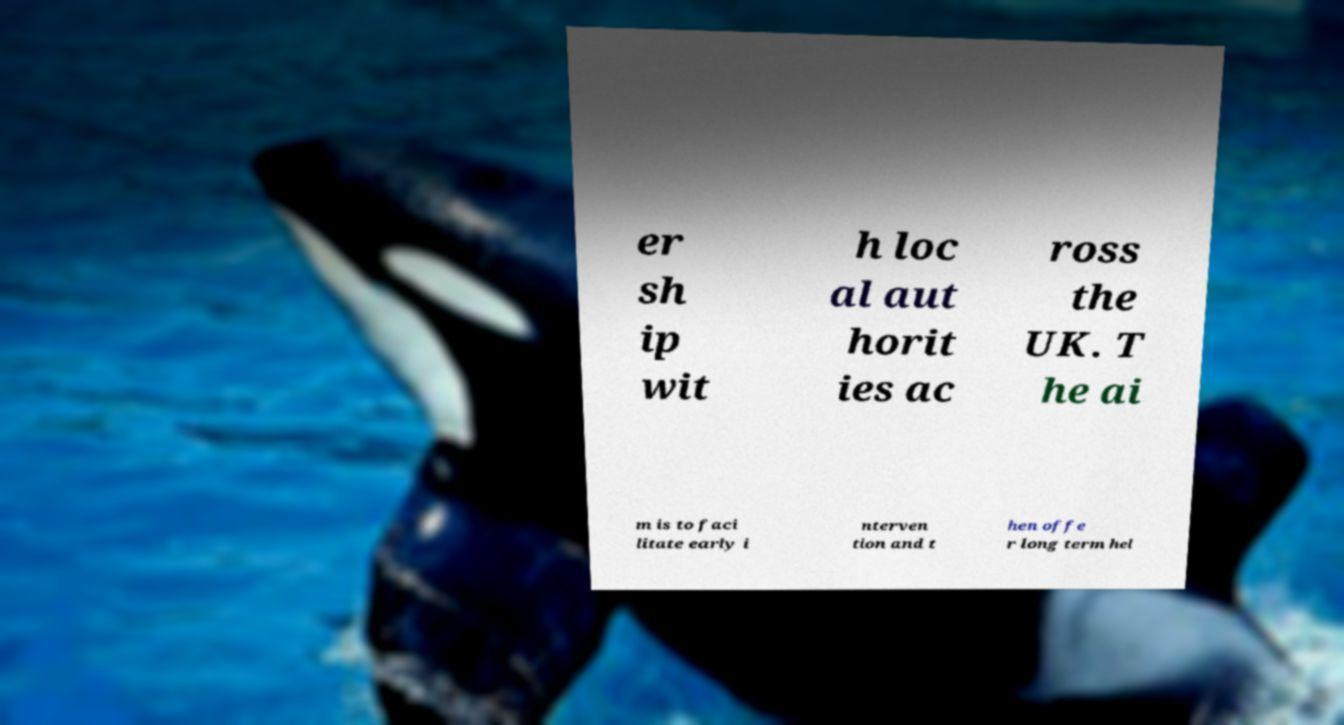Could you assist in decoding the text presented in this image and type it out clearly? er sh ip wit h loc al aut horit ies ac ross the UK. T he ai m is to faci litate early i nterven tion and t hen offe r long term hel 